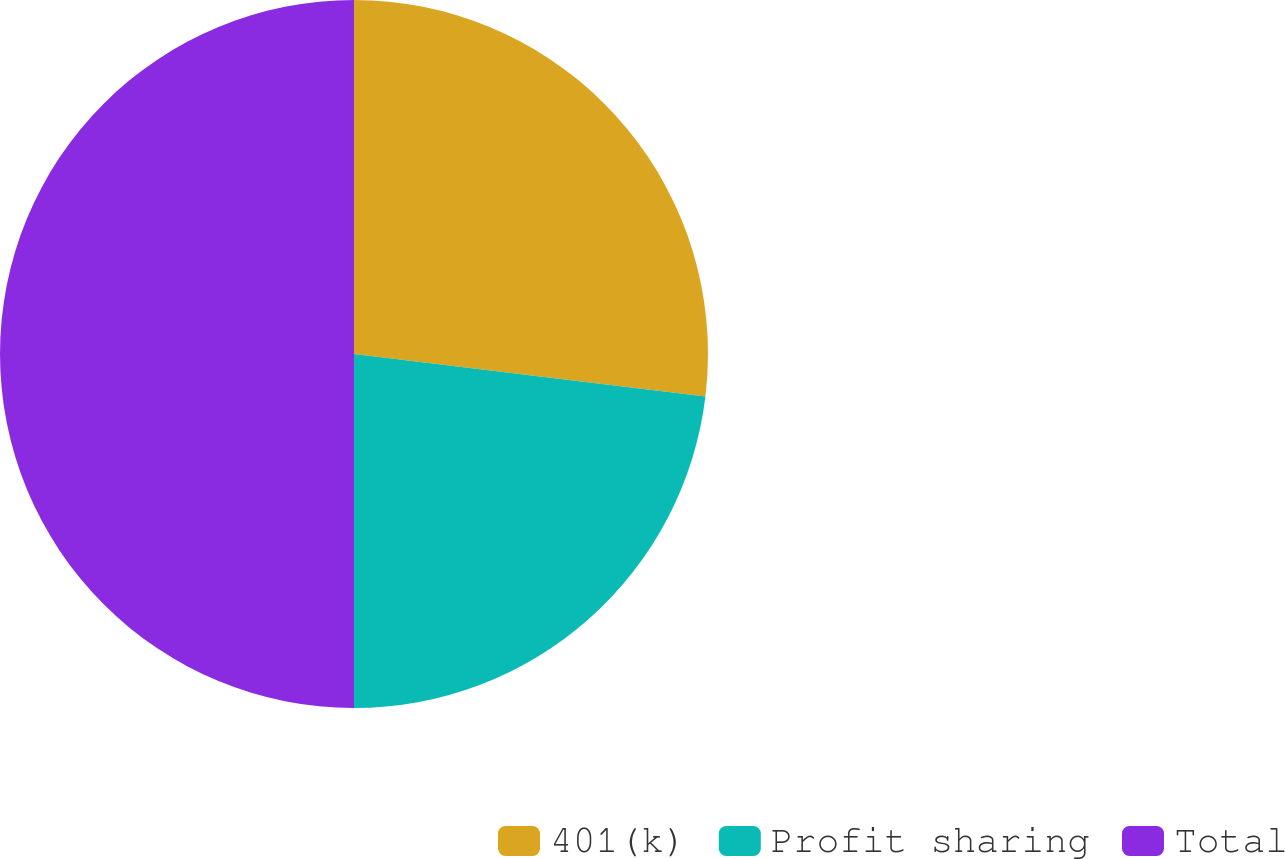Convert chart. <chart><loc_0><loc_0><loc_500><loc_500><pie_chart><fcel>401(k)<fcel>Profit sharing<fcel>Total<nl><fcel>26.92%<fcel>23.08%<fcel>50.0%<nl></chart> 